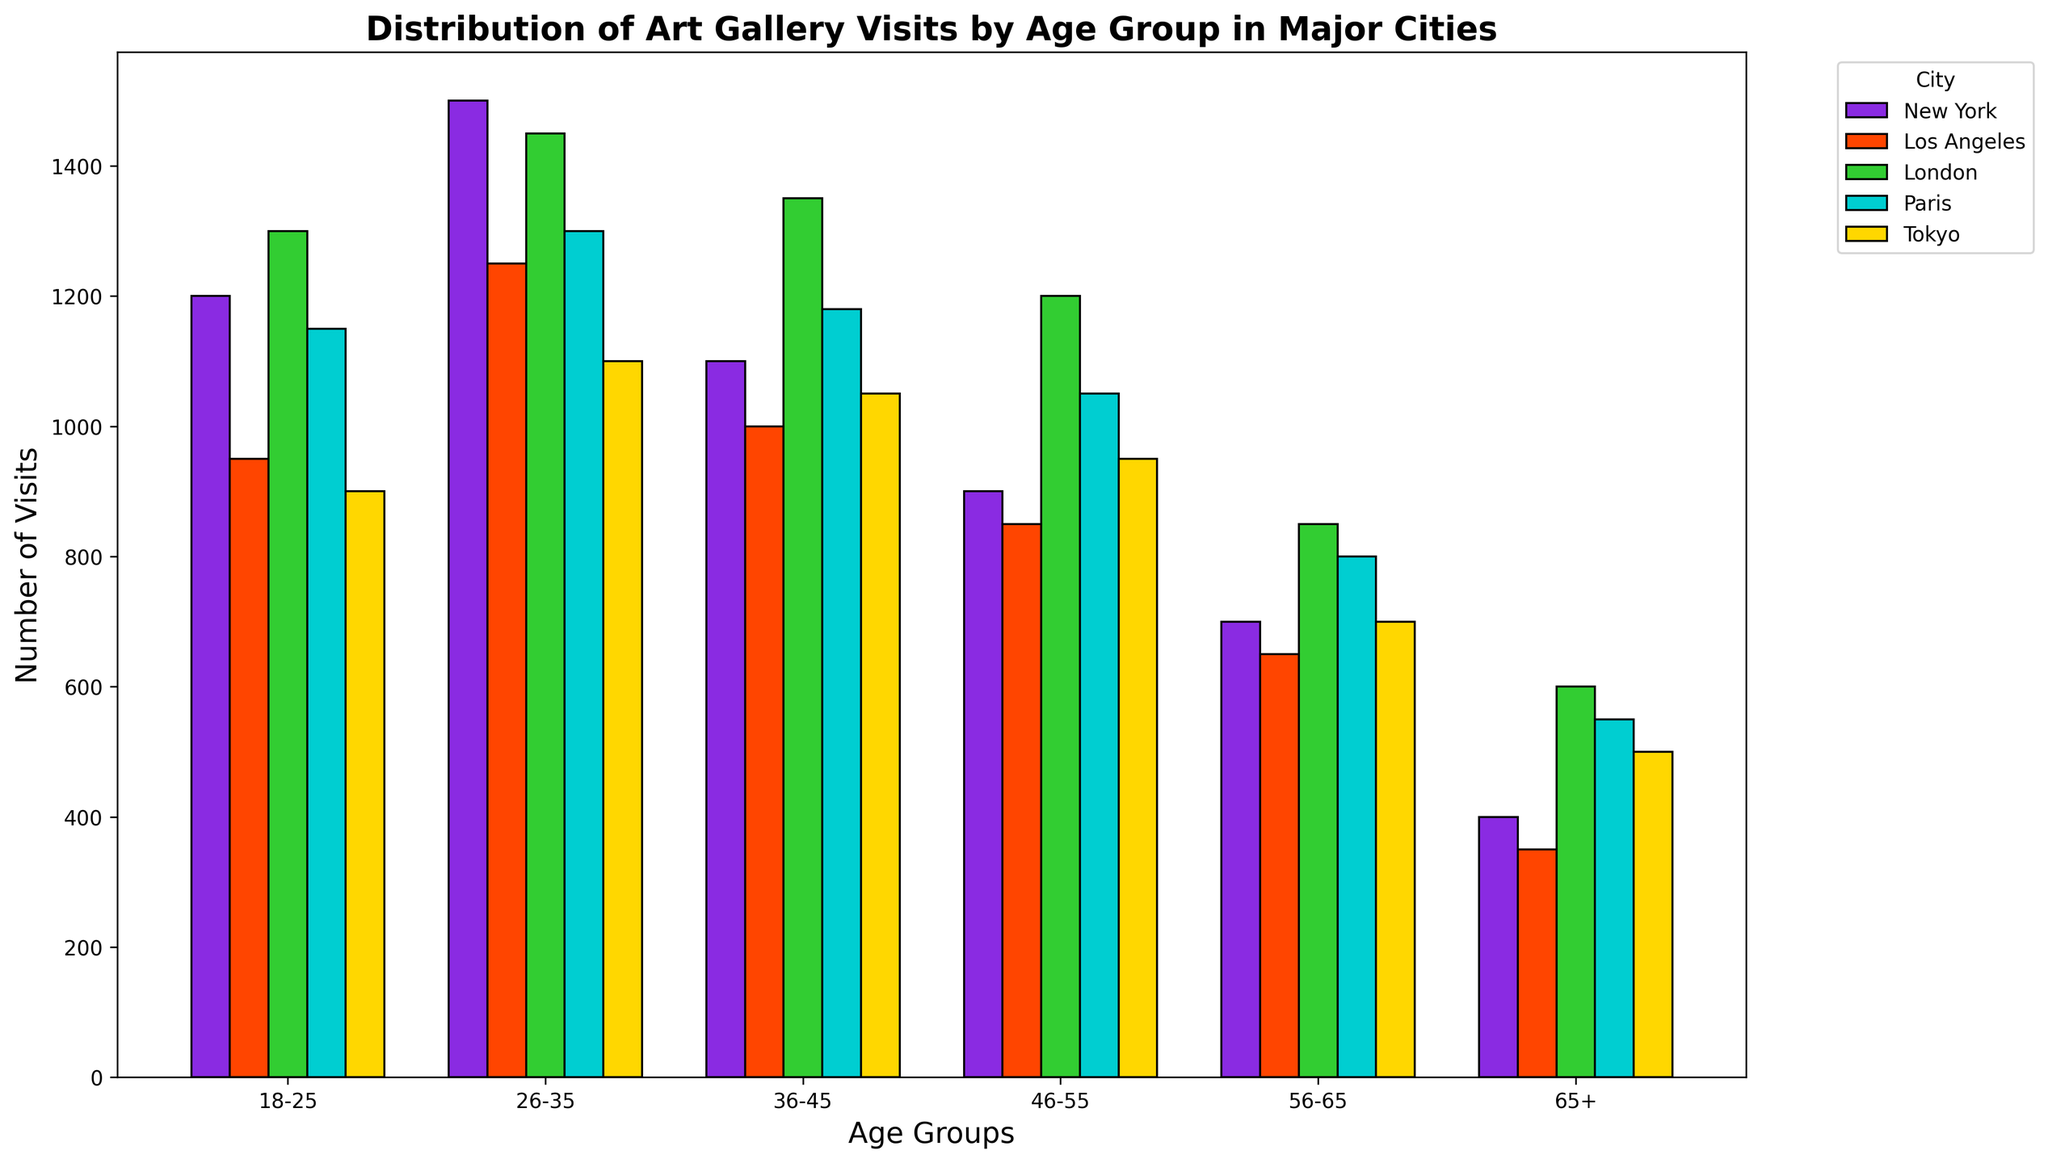Which city has the highest number of art gallery visits for the 18-25 age group? First, identify the bar for the 18-25 age group in each city, then compare their heights. New York has the highest bar among them.
Answer: New York How does the number of visits for 26-35 year-olds in Paris compare to that of Tokyo? Locate the bars for the 26-35 age group in Paris and Tokyo, and compare their heights. Paris has a taller bar than Tokyo.
Answer: Paris > Tokyo Which age group is least represented in gallery visits in Los Angeles? Identify the shortest bar among the age groups for Los Angeles. The 65+ age group has the shortest bar.
Answer: 65+ What is the total number of visits by the 56-65 age group across all cities? Sum the values for the 56-65 age group: (700 in New York) + (650 in Los Angeles) + (850 in London) + (800 in Paris) + (700 in Tokyo) = 3700.
Answer: 3700 Which city has the most even distribution of gallery visits across age groups? Compare the variation in bar heights for each city to determine which one has the smallest differences in heights among age groups. Los Angeles appears to have the most even distribution.
Answer: Los Angeles What is the average number of visits for the 36-45 age group across all cities? Sum the values for the 36-45 age group: (1100 in New York) + (1000 in Los Angeles) + (1350 in London) + (1180 in Paris) + (1050 in Tokyo) = 5680. Divide by the number of cities (5): 5680 / 5 = 1136.
Answer: 1136 Is the number of gallery visits by the 46-55 age group in Tokyo greater than in Paris? Compare the bar heights for the 46-55 age group. Tokyo has 950 visits, and Paris has 1050 visits, so Tokyo has fewer visits.
Answer: No What is the relative difference in the number of visits between the 18-25 and 65+ age groups in London? Subtract the number of visits for the 65+ age group from the 18-25 age group in London: 1300 - 600 = 700.
Answer: 700 Which age group has the highest number of visitors in Tokyo? Identify the tallest bar among the age groups in Tokyo. The 26-35 age group has the tallest bar.
Answer: 26-35 How many more visits does the 26-35 age group have compared to the 56-65 age group in New York? Subtract the number of visits for the 56-65 age group from the 26-35 age group in New York: 1500 - 700 = 800.
Answer: 800 